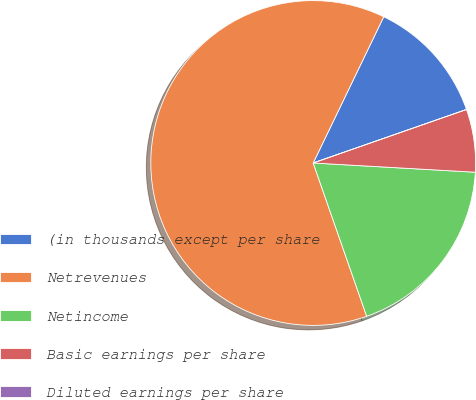<chart> <loc_0><loc_0><loc_500><loc_500><pie_chart><fcel>(in thousands except per share<fcel>Netrevenues<fcel>Netincome<fcel>Basic earnings per share<fcel>Diluted earnings per share<nl><fcel>12.5%<fcel>62.5%<fcel>18.75%<fcel>6.25%<fcel>0.0%<nl></chart> 